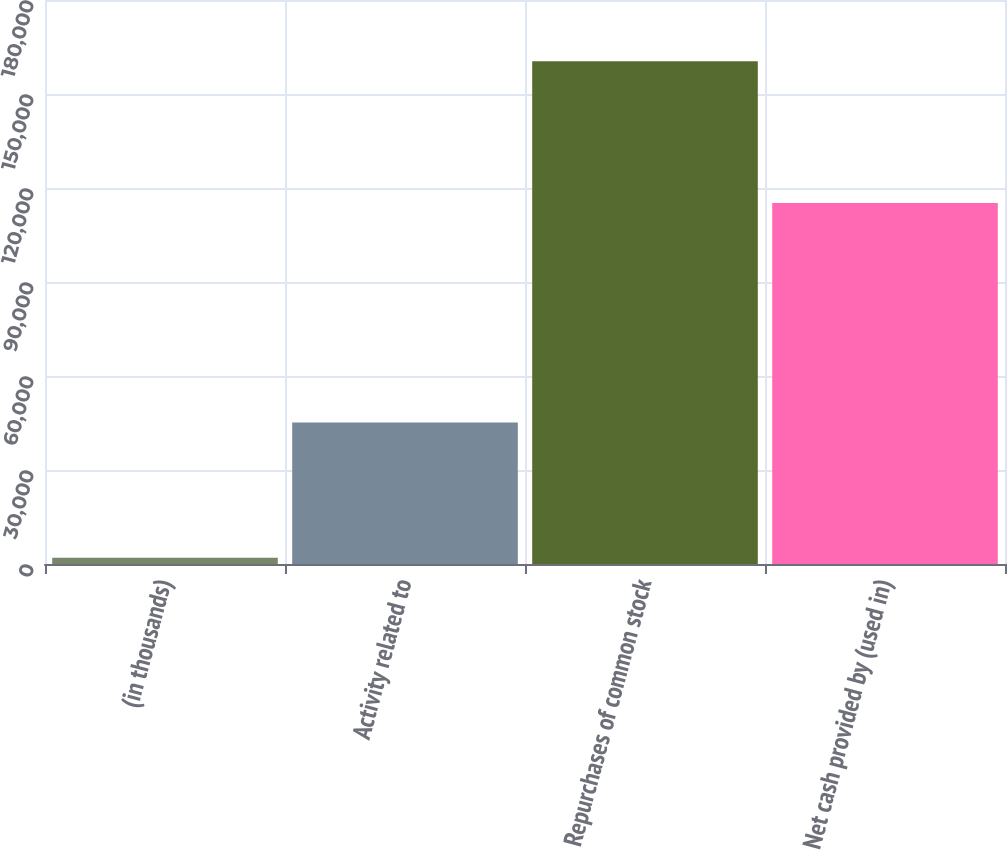Convert chart. <chart><loc_0><loc_0><loc_500><loc_500><bar_chart><fcel>(in thousands)<fcel>Activity related to<fcel>Repurchases of common stock<fcel>Net cash provided by (used in)<nl><fcel>2013<fcel>45176<fcel>160419<fcel>115243<nl></chart> 